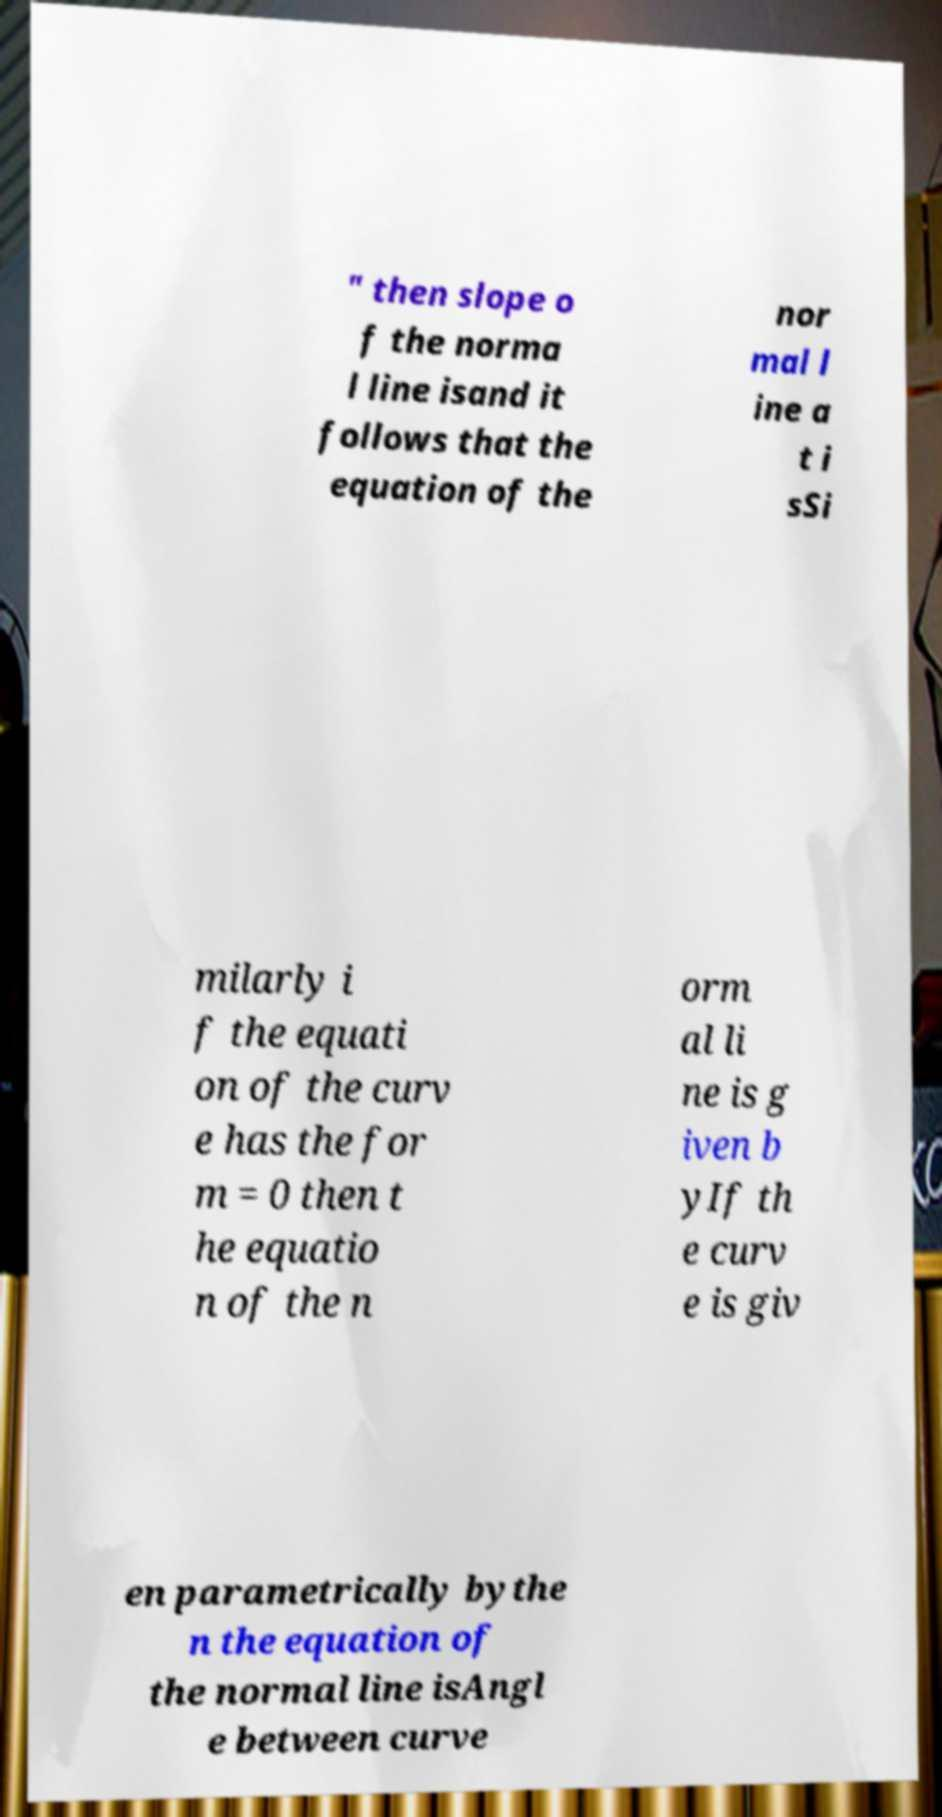There's text embedded in this image that I need extracted. Can you transcribe it verbatim? " then slope o f the norma l line isand it follows that the equation of the nor mal l ine a t i sSi milarly i f the equati on of the curv e has the for m = 0 then t he equatio n of the n orm al li ne is g iven b yIf th e curv e is giv en parametrically bythe n the equation of the normal line isAngl e between curve 